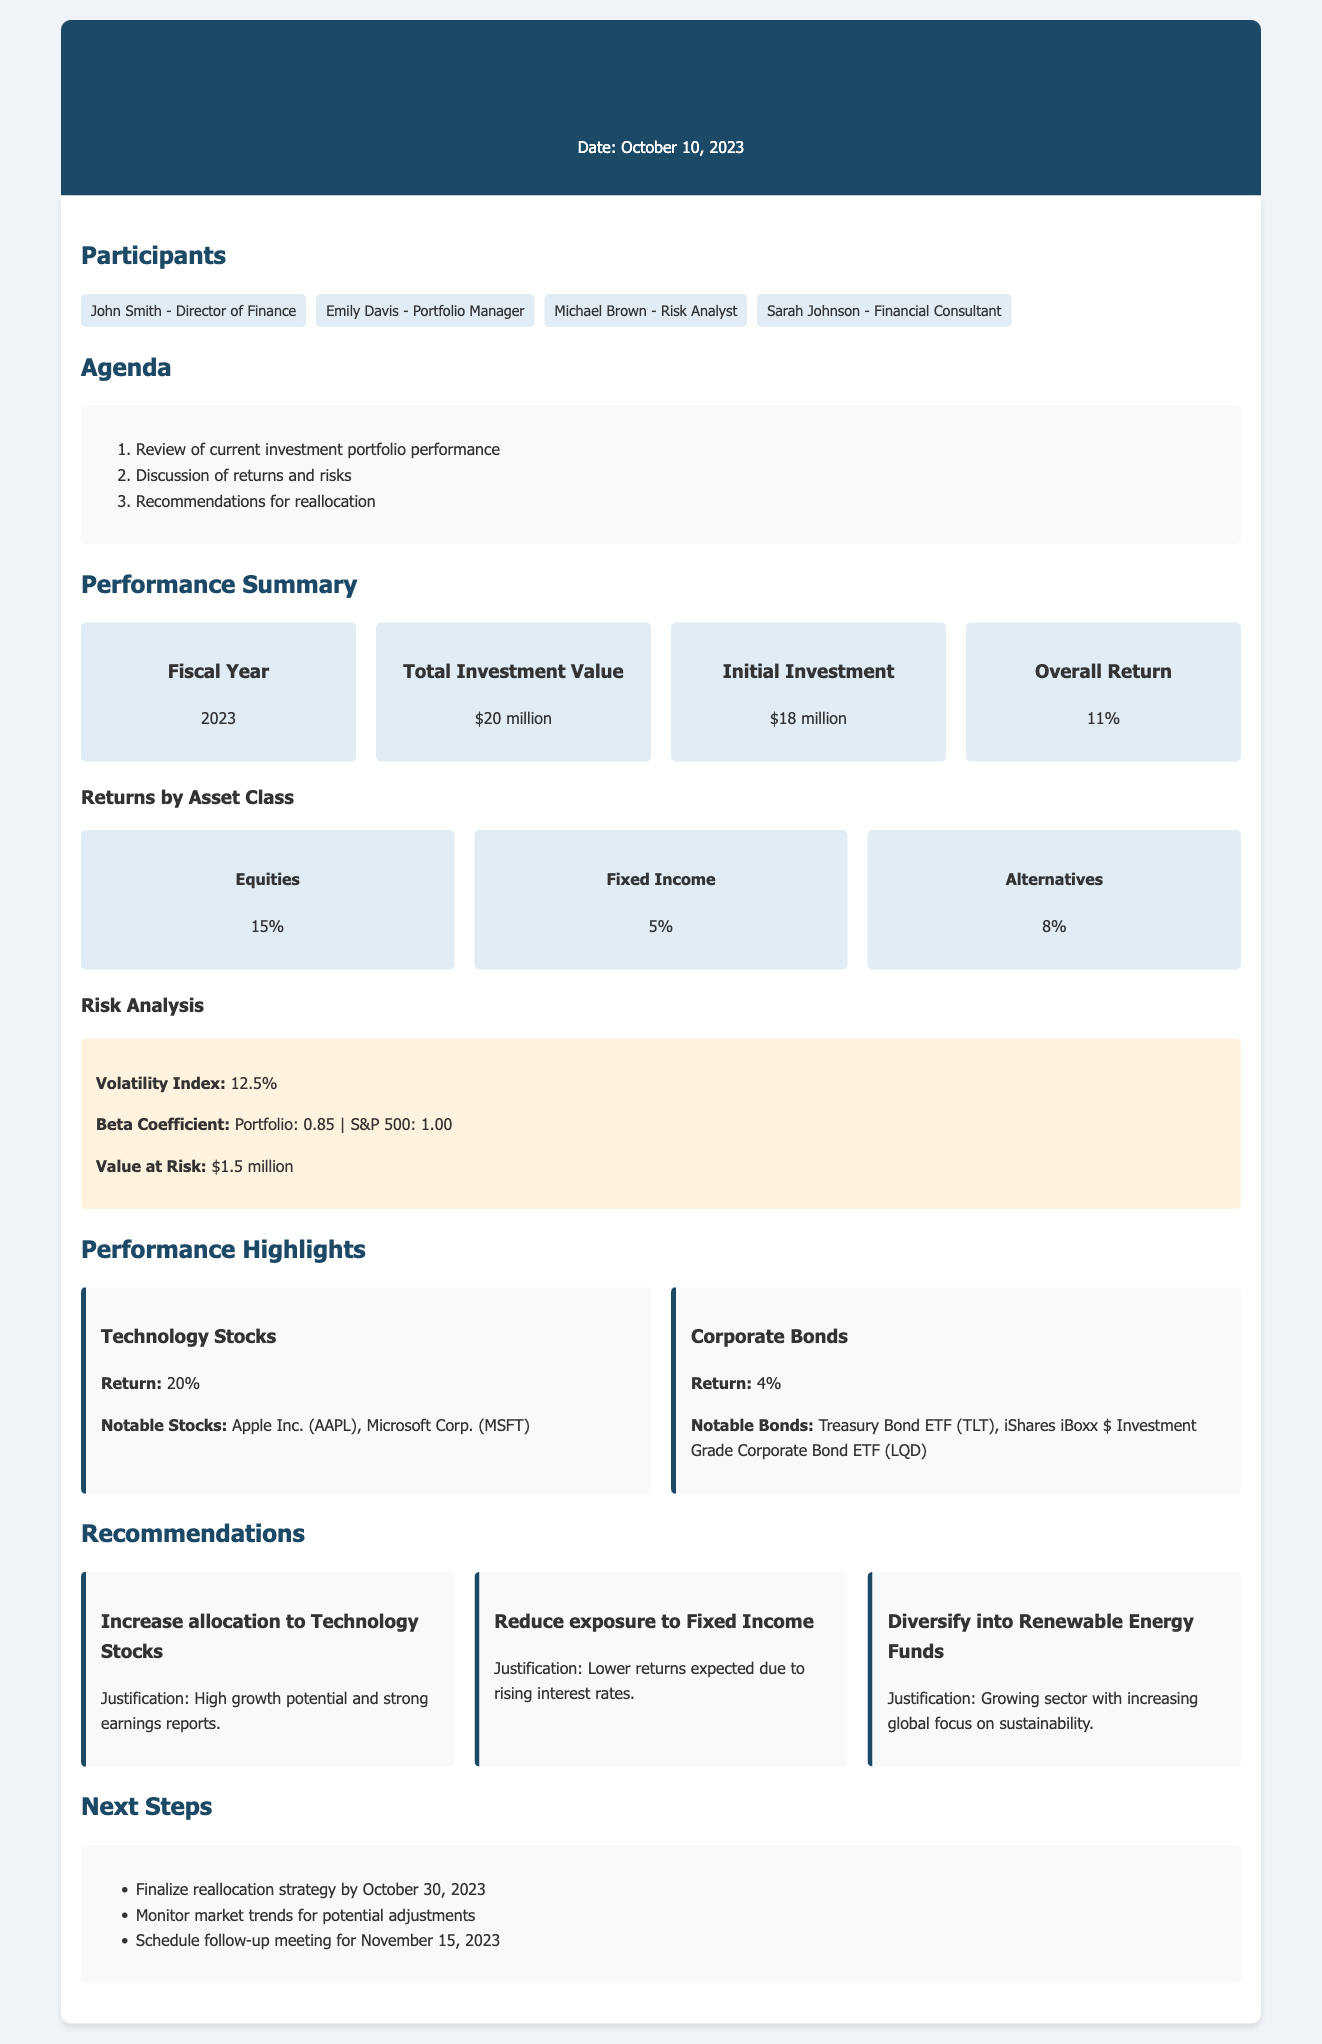What is the date of the meeting? The date of the meeting is mentioned at the top of the document as October 10, 2023.
Answer: October 10, 2023 What is the total investment value? The total investment value is presented in the performance summary as $20 million.
Answer: $20 million What was the overall return for the fiscal year? The overall return for the fiscal year is stated in the performance summary as 11%.
Answer: 11% Which asset class had the highest return? The highest return by asset class is indicated for Equities, with a return of 15%.
Answer: Equities What is the Value at Risk of the portfolio? The Value at Risk is specified in the risk analysis section as $1.5 million.
Answer: $1.5 million Why is it recommended to increase allocation to Technology Stocks? The justification for this recommendation is provided as high growth potential and strong earnings reports.
Answer: High growth potential and strong earnings reports What is the Beta Coefficient of the portfolio? The Beta Coefficient for the portfolio is stated as 0.85 in the risk analysis section.
Answer: 0.85 When is the follow-up meeting scheduled? The follow-up meeting date is listed in the next steps as November 15, 2023.
Answer: November 15, 2023 What is the initial investment amount? The initial investment amount is mentioned in the performance summary as $18 million.
Answer: $18 million 